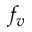<formula> <loc_0><loc_0><loc_500><loc_500>f _ { v }</formula> 